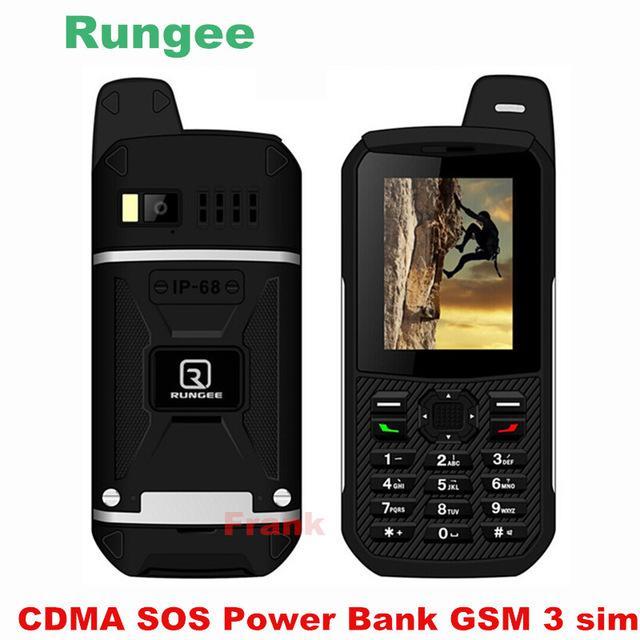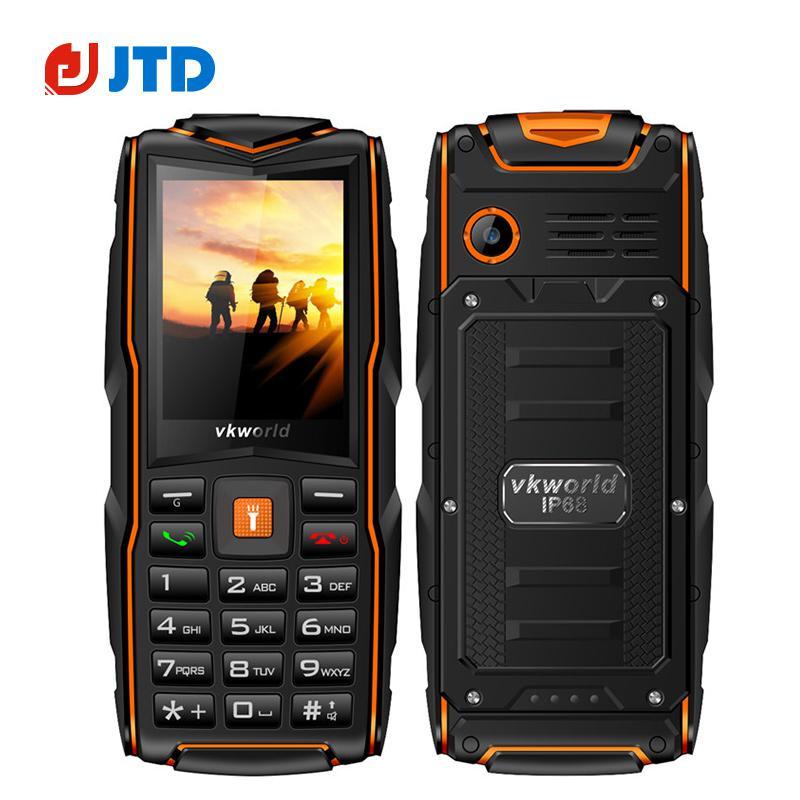The first image is the image on the left, the second image is the image on the right. Assess this claim about the two images: "One image contains just the front side of a phone and the other image shows both the front and back side of a phone.". Correct or not? Answer yes or no. No. The first image is the image on the left, the second image is the image on the right. Evaluate the accuracy of this statement regarding the images: "There are two phones in one of the images and one phone in the other.". Is it true? Answer yes or no. No. 